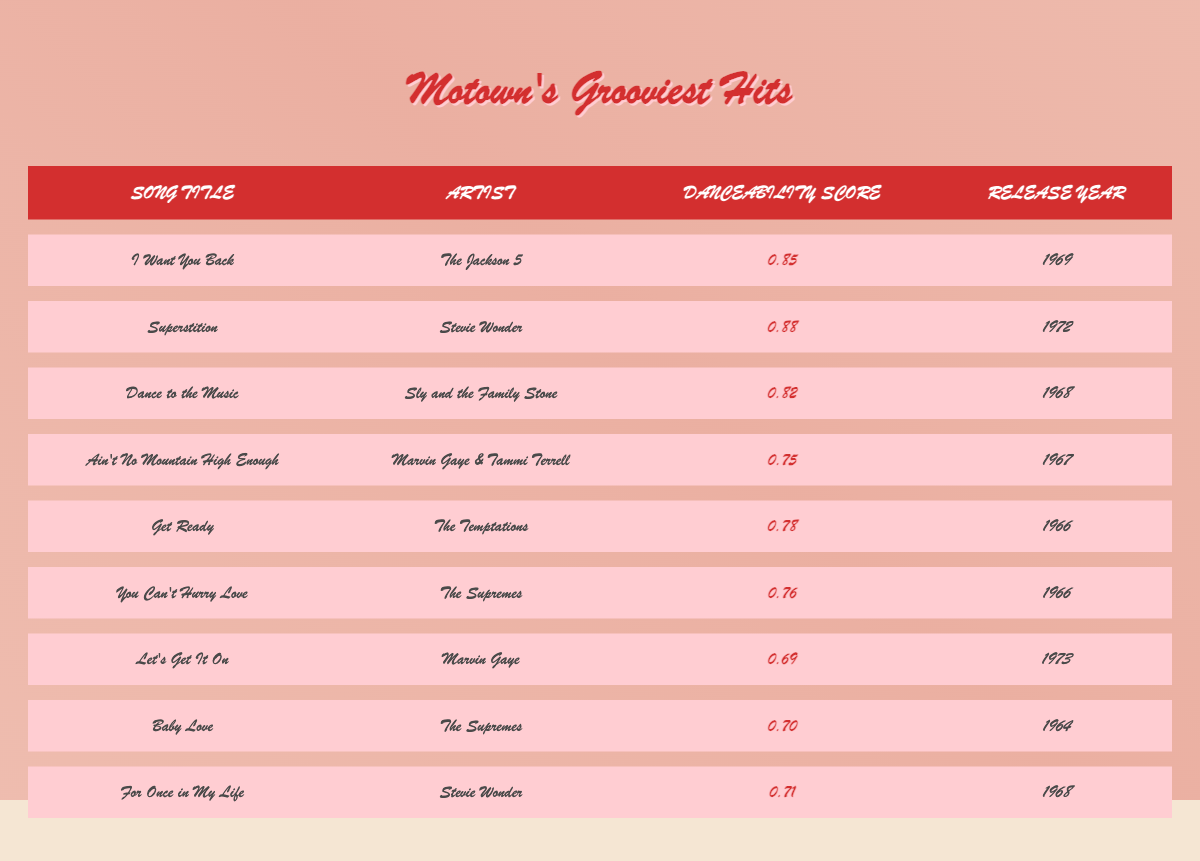What is the danceability score of "Superstition"? The table lists "Superstition" by Stevie Wonder with a danceability score of 0.88.
Answer: 0.88 Which artist performed "I Want You Back"? The table shows that "I Want You Back" is performed by The Jackson 5.
Answer: The Jackson 5 What is the release year of "You Can't Hurry Love"? The table indicates that "You Can't Hurry Love" was released in 1966.
Answer: 1966 Is "Let's Get It On" more danceable than "Ain't No Mountain High Enough"? "Let's Get It On" has a danceability score of 0.69, while "Ain't No Mountain High Enough" has a score of 0.75, meaning "Let's Get It On" is less danceable.
Answer: No What is the average danceability score of the songs released in 1968? The songs from 1968 are "Dance to the Music" (0.82), "For Once in My Life" (0.71). The average is (0.82 + 0.71) / 2 = 0.765.
Answer: 0.765 Which song has the lowest danceability score, and what is that score? By reviewing the table, "Let's Get It On" has the lowest danceability score of 0.69 among all listed songs.
Answer: Let's Get It On, 0.69 How many songs have a danceability score of 0.70 or higher? The songs above this score are "Superstition," "I Want You Back," "Dance to the Music," "Get Ready," "You Can't Hurry Love," "For Once in My Life," totaling 6 songs.
Answer: 6 Which song was released first: "Baby Love" or "Get Ready"? The table shows "Baby Love" was released in 1964 and "Get Ready" in 1966, thus "Baby Love" was released first.
Answer: Baby Love What is the difference in danceability score between "I Want You Back" and "Dance to the Music"? "I Want You Back" has a score of 0.85 and "Dance to the Music" has a score of 0.82. The difference is 0.85 - 0.82 = 0.03.
Answer: 0.03 